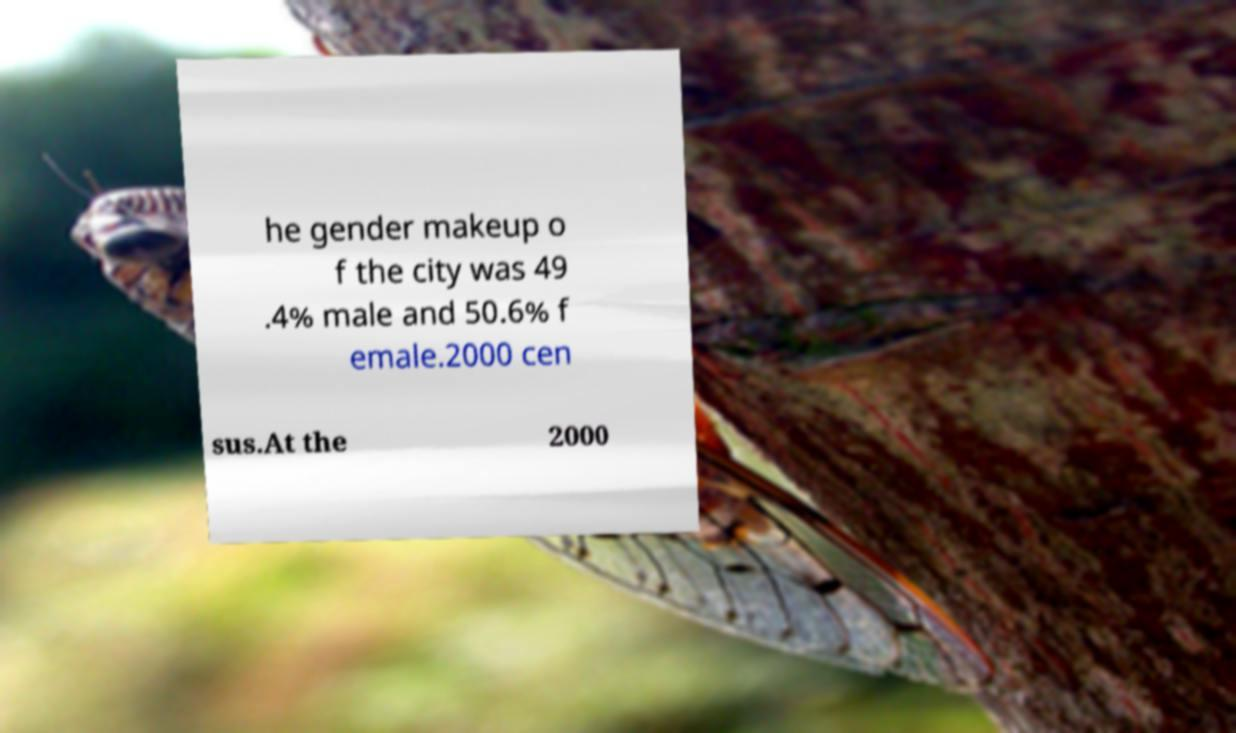What messages or text are displayed in this image? I need them in a readable, typed format. he gender makeup o f the city was 49 .4% male and 50.6% f emale.2000 cen sus.At the 2000 